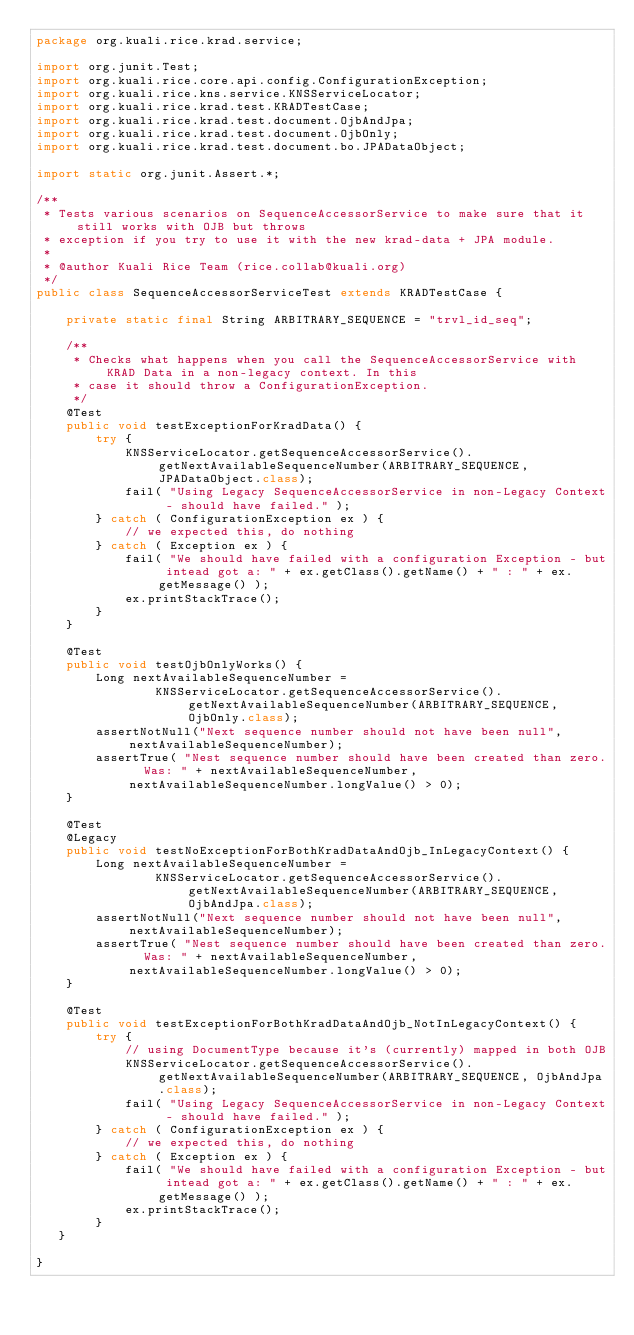<code> <loc_0><loc_0><loc_500><loc_500><_Java_>package org.kuali.rice.krad.service;

import org.junit.Test;
import org.kuali.rice.core.api.config.ConfigurationException;
import org.kuali.rice.kns.service.KNSServiceLocator;
import org.kuali.rice.krad.test.KRADTestCase;
import org.kuali.rice.krad.test.document.OjbAndJpa;
import org.kuali.rice.krad.test.document.OjbOnly;
import org.kuali.rice.krad.test.document.bo.JPADataObject;

import static org.junit.Assert.*;

/**
 * Tests various scenarios on SequenceAccessorService to make sure that it still works with OJB but throws
 * exception if you try to use it with the new krad-data + JPA module.
 *
 * @author Kuali Rice Team (rice.collab@kuali.org)
 */
public class SequenceAccessorServiceTest extends KRADTestCase {

    private static final String ARBITRARY_SEQUENCE = "trvl_id_seq";

    /**
     * Checks what happens when you call the SequenceAccessorService with KRAD Data in a non-legacy context. In this
     * case it should throw a ConfigurationException.
     */
    @Test
    public void testExceptionForKradData() {
        try {
            KNSServiceLocator.getSequenceAccessorService().getNextAvailableSequenceNumber(ARBITRARY_SEQUENCE, JPADataObject.class);
            fail( "Using Legacy SequenceAccessorService in non-Legacy Context - should have failed." );
        } catch ( ConfigurationException ex ) {
            // we expected this, do nothing
        } catch ( Exception ex ) {
            fail( "We should have failed with a configuration Exception - but intead got a: " + ex.getClass().getName() + " : " + ex.getMessage() );
            ex.printStackTrace();
        }
    }

    @Test
    public void testOjbOnlyWorks() {
        Long nextAvailableSequenceNumber =
                KNSServiceLocator.getSequenceAccessorService().getNextAvailableSequenceNumber(ARBITRARY_SEQUENCE, OjbOnly.class);
        assertNotNull("Next sequence number should not have been null",nextAvailableSequenceNumber);
        assertTrue( "Nest sequence number should have been created than zero.  Was: " + nextAvailableSequenceNumber, nextAvailableSequenceNumber.longValue() > 0);
    }

    @Test
    @Legacy
    public void testNoExceptionForBothKradDataAndOjb_InLegacyContext() {
        Long nextAvailableSequenceNumber =
                KNSServiceLocator.getSequenceAccessorService().getNextAvailableSequenceNumber(ARBITRARY_SEQUENCE, OjbAndJpa.class);
        assertNotNull("Next sequence number should not have been null",nextAvailableSequenceNumber);
        assertTrue( "Nest sequence number should have been created than zero.  Was: " + nextAvailableSequenceNumber, nextAvailableSequenceNumber.longValue() > 0);
    }

    @Test
    public void testExceptionForBothKradDataAndOjb_NotInLegacyContext() {
        try {
            // using DocumentType because it's (currently) mapped in both OJB
            KNSServiceLocator.getSequenceAccessorService().getNextAvailableSequenceNumber(ARBITRARY_SEQUENCE, OjbAndJpa.class);
            fail( "Using Legacy SequenceAccessorService in non-Legacy Context - should have failed." );
        } catch ( ConfigurationException ex ) {
            // we expected this, do nothing
        } catch ( Exception ex ) {
            fail( "We should have failed with a configuration Exception - but intead got a: " + ex.getClass().getName() + " : " + ex.getMessage() );
            ex.printStackTrace();
        }
   }

}</code> 